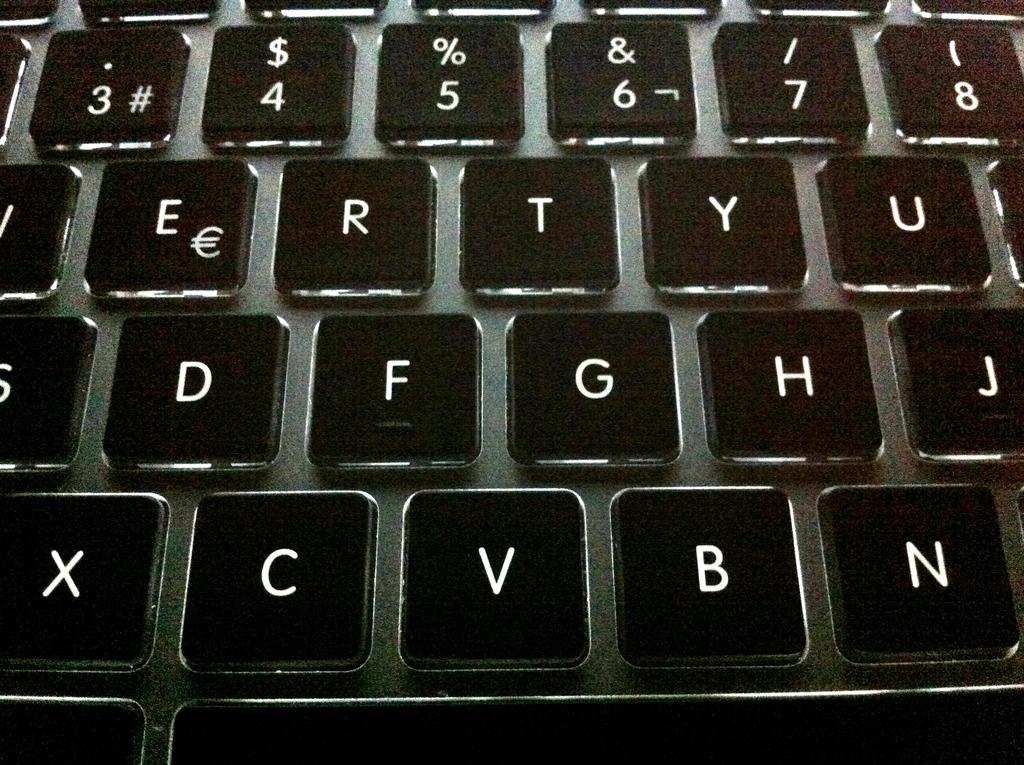<image>
Relay a brief, clear account of the picture shown. a light up keyboard with the letters e, r, t, y , and u in the middle 